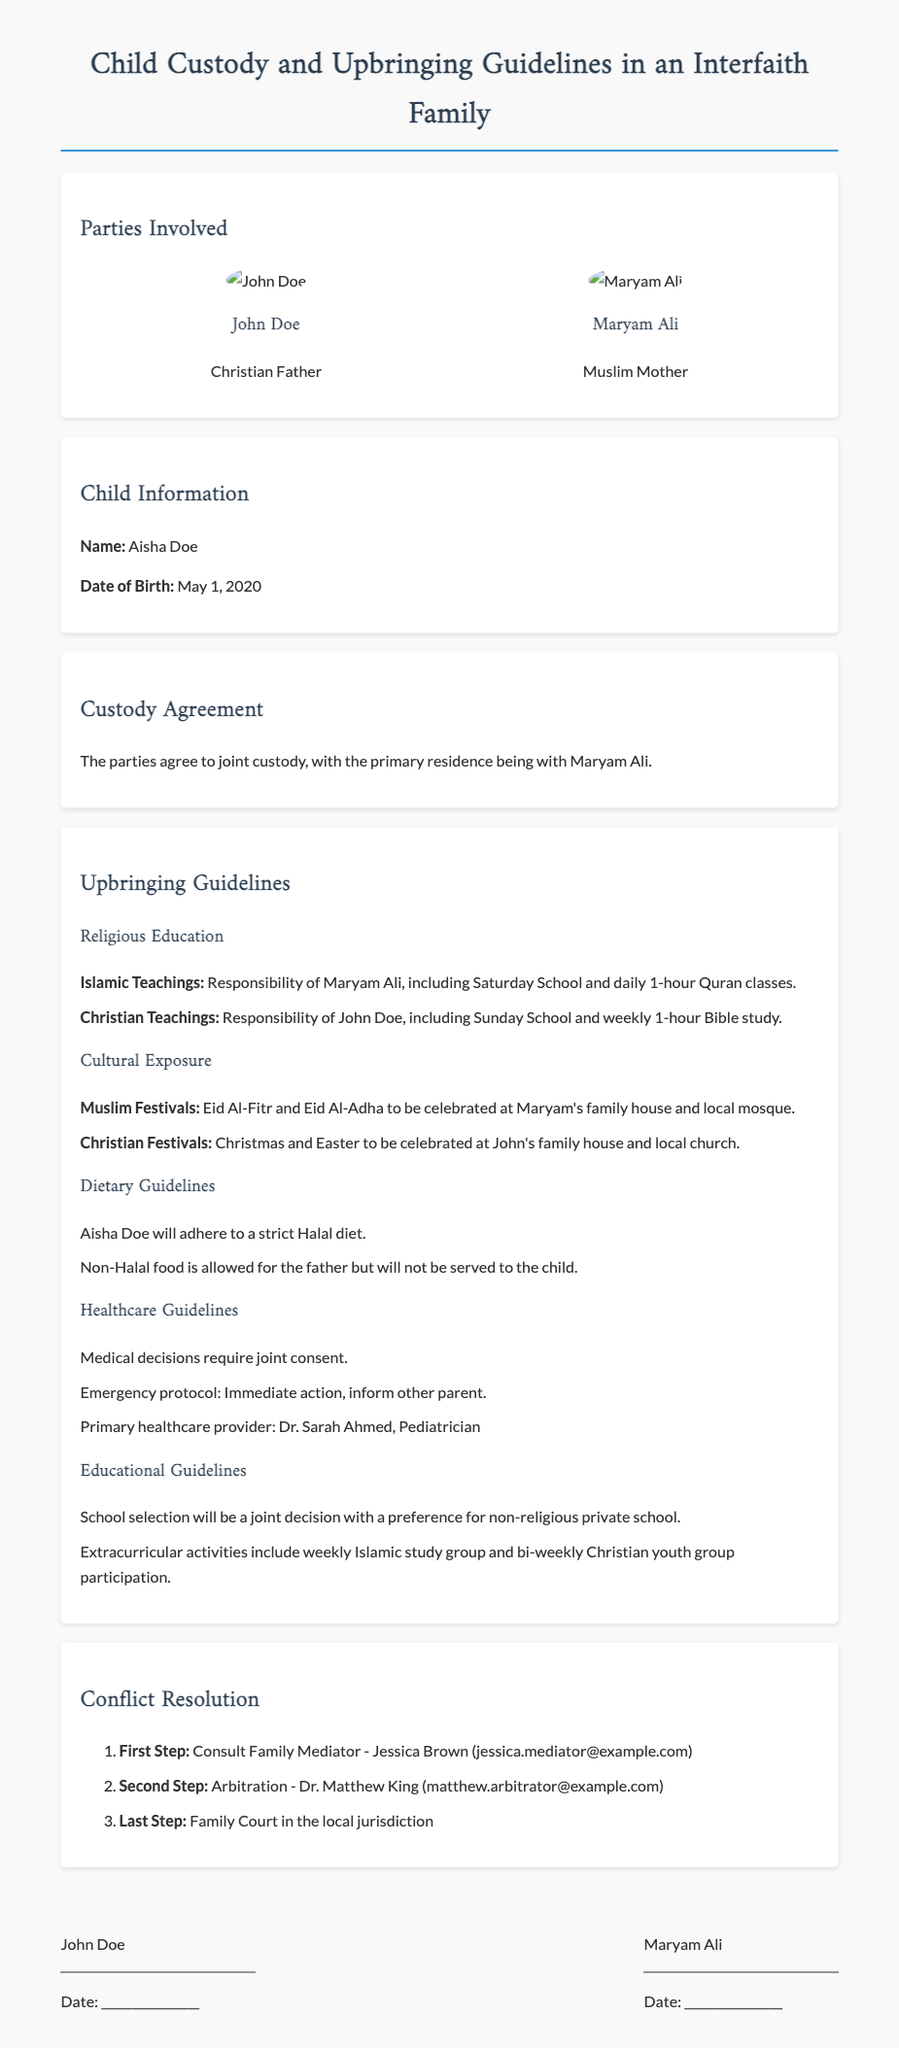What is the child's name? The child's name is provided in the "Child Information" section of the document.
Answer: Aisha Doe Who has the primary residence? The custody agreement specifies who has the primary residence in the document.
Answer: Maryam Ali What type of dietary guidelines does Aisha Doe follow? The document outlines specific dietary guidelines under "Dietary Guidelines."
Answer: Halal diet What is the name of the family mediator? The conflict resolution section identifies the family mediator that the parties should consult first.
Answer: Jessica Brown How often does Aisha attend Quran classes? The upbringing guidelines detail the frequency of religious education for Aisha.
Answer: daily 1-hour What are the Christian festivals mentioned in the document? The upbringing guidelines specify which festivals the Christian father will celebrate with the child.
Answer: Christmas and Easter Which healthcare provider is listed as the primary healthcare provider? The healthcare guidelines include the name of the pediatrician for the child.
Answer: Dr. Sarah Ahmed What is the last step in the conflict resolution process? The conflict resolution section provides a hierarchy of resolution steps, including the final step.
Answer: Family Court in the local jurisdiction What type of school is preferred for Aisha's education? The educational guidelines indicate the desired type of school for Aisha.
Answer: non-religious private school 